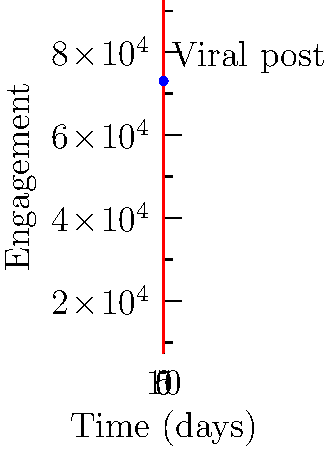In the graph above, engagement of a social media post is modeled by the logistic function $E(t) = \frac{100000}{1+e^{-0.5(t-5)}}$, where $E$ is the engagement level and $t$ is time in days. A viral post occurs at the point marked on the graph. What are the coordinates of this viral post, rounded to the nearest whole number? To find the coordinates of the viral post, we need to:

1. Identify the x-coordinate (time) from the graph:
   The blue dot appears to be at $t = 7$ days.

2. Calculate the y-coordinate (engagement) using the given function:
   $E(7) = \frac{100000}{1+e^{-0.5(7-5)}}$

3. Simplify:
   $E(7) = \frac{100000}{1+e^{-1}}$

4. Calculate:
   $E(7) = \frac{100000}{1+0.3679} \approx 73,106$

5. Round to the nearest whole number:
   $E(7) \approx 73,106$

Therefore, the coordinates of the viral post are approximately (7, 73106).
Answer: (7, 73106) 